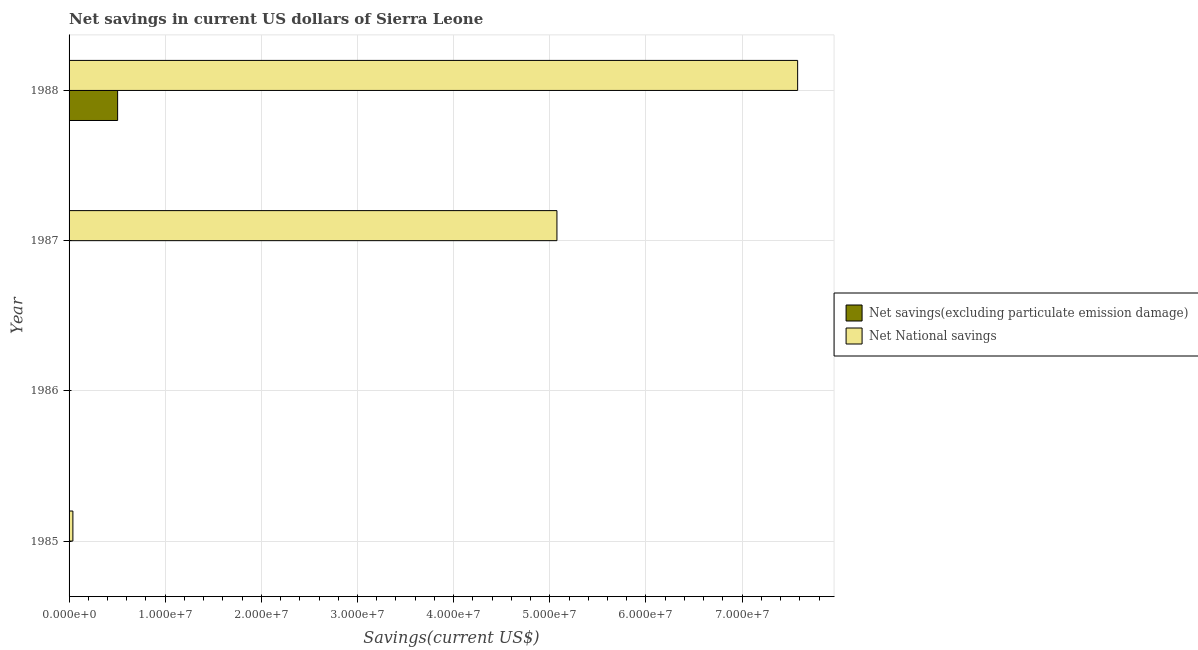Are the number of bars on each tick of the Y-axis equal?
Offer a terse response. No. What is the label of the 2nd group of bars from the top?
Provide a short and direct response. 1987. What is the net national savings in 1987?
Keep it short and to the point. 5.07e+07. Across all years, what is the maximum net national savings?
Offer a terse response. 7.58e+07. Across all years, what is the minimum net national savings?
Offer a very short reply. 0. What is the total net savings(excluding particulate emission damage) in the graph?
Provide a succinct answer. 5.05e+06. What is the difference between the net national savings in 1987 and that in 1988?
Your answer should be very brief. -2.50e+07. What is the difference between the net national savings in 1985 and the net savings(excluding particulate emission damage) in 1988?
Ensure brevity in your answer.  -4.65e+06. What is the average net savings(excluding particulate emission damage) per year?
Make the answer very short. 1.26e+06. In the year 1988, what is the difference between the net savings(excluding particulate emission damage) and net national savings?
Keep it short and to the point. -7.07e+07. In how many years, is the net national savings greater than 42000000 US$?
Offer a terse response. 2. What is the ratio of the net national savings in 1987 to that in 1988?
Give a very brief answer. 0.67. Is the net national savings in 1985 less than that in 1988?
Your answer should be very brief. Yes. What is the difference between the highest and the second highest net national savings?
Provide a succinct answer. 2.50e+07. What is the difference between the highest and the lowest net savings(excluding particulate emission damage)?
Ensure brevity in your answer.  5.05e+06. In how many years, is the net savings(excluding particulate emission damage) greater than the average net savings(excluding particulate emission damage) taken over all years?
Your response must be concise. 1. How many bars are there?
Provide a succinct answer. 4. What is the difference between two consecutive major ticks on the X-axis?
Provide a succinct answer. 1.00e+07. Are the values on the major ticks of X-axis written in scientific E-notation?
Your response must be concise. Yes. How are the legend labels stacked?
Provide a succinct answer. Vertical. What is the title of the graph?
Keep it short and to the point. Net savings in current US dollars of Sierra Leone. What is the label or title of the X-axis?
Provide a short and direct response. Savings(current US$). What is the Savings(current US$) in Net National savings in 1985?
Your answer should be very brief. 3.97e+05. What is the Savings(current US$) of Net savings(excluding particulate emission damage) in 1987?
Provide a short and direct response. 0. What is the Savings(current US$) in Net National savings in 1987?
Provide a succinct answer. 5.07e+07. What is the Savings(current US$) of Net savings(excluding particulate emission damage) in 1988?
Provide a succinct answer. 5.05e+06. What is the Savings(current US$) in Net National savings in 1988?
Offer a very short reply. 7.58e+07. Across all years, what is the maximum Savings(current US$) in Net savings(excluding particulate emission damage)?
Offer a very short reply. 5.05e+06. Across all years, what is the maximum Savings(current US$) of Net National savings?
Offer a very short reply. 7.58e+07. Across all years, what is the minimum Savings(current US$) in Net savings(excluding particulate emission damage)?
Offer a very short reply. 0. What is the total Savings(current US$) of Net savings(excluding particulate emission damage) in the graph?
Make the answer very short. 5.05e+06. What is the total Savings(current US$) in Net National savings in the graph?
Offer a very short reply. 1.27e+08. What is the difference between the Savings(current US$) of Net National savings in 1985 and that in 1987?
Make the answer very short. -5.03e+07. What is the difference between the Savings(current US$) in Net National savings in 1985 and that in 1988?
Offer a terse response. -7.54e+07. What is the difference between the Savings(current US$) in Net National savings in 1987 and that in 1988?
Your response must be concise. -2.50e+07. What is the average Savings(current US$) in Net savings(excluding particulate emission damage) per year?
Make the answer very short. 1.26e+06. What is the average Savings(current US$) in Net National savings per year?
Give a very brief answer. 3.17e+07. In the year 1988, what is the difference between the Savings(current US$) of Net savings(excluding particulate emission damage) and Savings(current US$) of Net National savings?
Offer a very short reply. -7.07e+07. What is the ratio of the Savings(current US$) of Net National savings in 1985 to that in 1987?
Provide a succinct answer. 0.01. What is the ratio of the Savings(current US$) in Net National savings in 1985 to that in 1988?
Your answer should be compact. 0.01. What is the ratio of the Savings(current US$) of Net National savings in 1987 to that in 1988?
Your answer should be compact. 0.67. What is the difference between the highest and the second highest Savings(current US$) in Net National savings?
Provide a succinct answer. 2.50e+07. What is the difference between the highest and the lowest Savings(current US$) in Net savings(excluding particulate emission damage)?
Ensure brevity in your answer.  5.05e+06. What is the difference between the highest and the lowest Savings(current US$) in Net National savings?
Provide a short and direct response. 7.58e+07. 